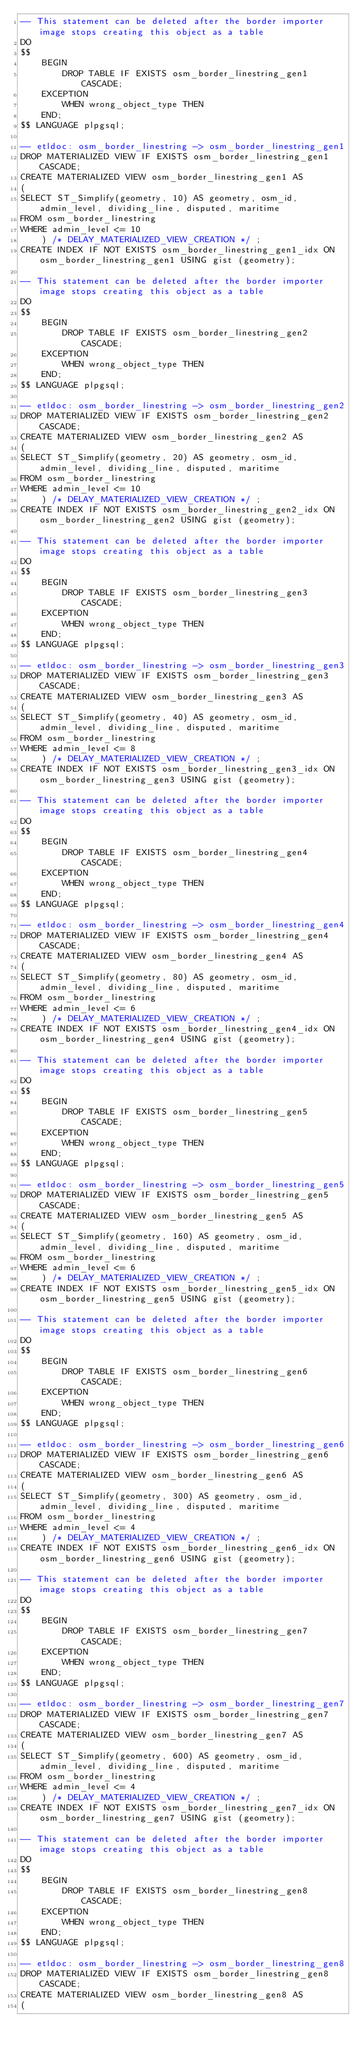<code> <loc_0><loc_0><loc_500><loc_500><_SQL_>-- This statement can be deleted after the border importer image stops creating this object as a table
DO
$$
    BEGIN
        DROP TABLE IF EXISTS osm_border_linestring_gen1 CASCADE;
    EXCEPTION
        WHEN wrong_object_type THEN
    END;
$$ LANGUAGE plpgsql;

-- etldoc: osm_border_linestring -> osm_border_linestring_gen1
DROP MATERIALIZED VIEW IF EXISTS osm_border_linestring_gen1 CASCADE;
CREATE MATERIALIZED VIEW osm_border_linestring_gen1 AS
(
SELECT ST_Simplify(geometry, 10) AS geometry, osm_id, admin_level, dividing_line, disputed, maritime
FROM osm_border_linestring
WHERE admin_level <= 10
    ) /* DELAY_MATERIALIZED_VIEW_CREATION */ ;
CREATE INDEX IF NOT EXISTS osm_border_linestring_gen1_idx ON osm_border_linestring_gen1 USING gist (geometry);

-- This statement can be deleted after the border importer image stops creating this object as a table
DO
$$
    BEGIN
        DROP TABLE IF EXISTS osm_border_linestring_gen2 CASCADE;
    EXCEPTION
        WHEN wrong_object_type THEN
    END;
$$ LANGUAGE plpgsql;

-- etldoc: osm_border_linestring -> osm_border_linestring_gen2
DROP MATERIALIZED VIEW IF EXISTS osm_border_linestring_gen2 CASCADE;
CREATE MATERIALIZED VIEW osm_border_linestring_gen2 AS
(
SELECT ST_Simplify(geometry, 20) AS geometry, osm_id, admin_level, dividing_line, disputed, maritime
FROM osm_border_linestring
WHERE admin_level <= 10
    ) /* DELAY_MATERIALIZED_VIEW_CREATION */ ;
CREATE INDEX IF NOT EXISTS osm_border_linestring_gen2_idx ON osm_border_linestring_gen2 USING gist (geometry);

-- This statement can be deleted after the border importer image stops creating this object as a table
DO
$$
    BEGIN
        DROP TABLE IF EXISTS osm_border_linestring_gen3 CASCADE;
    EXCEPTION
        WHEN wrong_object_type THEN
    END;
$$ LANGUAGE plpgsql;

-- etldoc: osm_border_linestring -> osm_border_linestring_gen3
DROP MATERIALIZED VIEW IF EXISTS osm_border_linestring_gen3 CASCADE;
CREATE MATERIALIZED VIEW osm_border_linestring_gen3 AS
(
SELECT ST_Simplify(geometry, 40) AS geometry, osm_id, admin_level, dividing_line, disputed, maritime
FROM osm_border_linestring
WHERE admin_level <= 8
    ) /* DELAY_MATERIALIZED_VIEW_CREATION */ ;
CREATE INDEX IF NOT EXISTS osm_border_linestring_gen3_idx ON osm_border_linestring_gen3 USING gist (geometry);

-- This statement can be deleted after the border importer image stops creating this object as a table
DO
$$
    BEGIN
        DROP TABLE IF EXISTS osm_border_linestring_gen4 CASCADE;
    EXCEPTION
        WHEN wrong_object_type THEN
    END;
$$ LANGUAGE plpgsql;

-- etldoc: osm_border_linestring -> osm_border_linestring_gen4
DROP MATERIALIZED VIEW IF EXISTS osm_border_linestring_gen4 CASCADE;
CREATE MATERIALIZED VIEW osm_border_linestring_gen4 AS
(
SELECT ST_Simplify(geometry, 80) AS geometry, osm_id, admin_level, dividing_line, disputed, maritime
FROM osm_border_linestring
WHERE admin_level <= 6
    ) /* DELAY_MATERIALIZED_VIEW_CREATION */ ;
CREATE INDEX IF NOT EXISTS osm_border_linestring_gen4_idx ON osm_border_linestring_gen4 USING gist (geometry);

-- This statement can be deleted after the border importer image stops creating this object as a table
DO
$$
    BEGIN
        DROP TABLE IF EXISTS osm_border_linestring_gen5 CASCADE;
    EXCEPTION
        WHEN wrong_object_type THEN
    END;
$$ LANGUAGE plpgsql;

-- etldoc: osm_border_linestring -> osm_border_linestring_gen5
DROP MATERIALIZED VIEW IF EXISTS osm_border_linestring_gen5 CASCADE;
CREATE MATERIALIZED VIEW osm_border_linestring_gen5 AS
(
SELECT ST_Simplify(geometry, 160) AS geometry, osm_id, admin_level, dividing_line, disputed, maritime
FROM osm_border_linestring
WHERE admin_level <= 6
    ) /* DELAY_MATERIALIZED_VIEW_CREATION */ ;
CREATE INDEX IF NOT EXISTS osm_border_linestring_gen5_idx ON osm_border_linestring_gen5 USING gist (geometry);

-- This statement can be deleted after the border importer image stops creating this object as a table
DO
$$
    BEGIN
        DROP TABLE IF EXISTS osm_border_linestring_gen6 CASCADE;
    EXCEPTION
        WHEN wrong_object_type THEN
    END;
$$ LANGUAGE plpgsql;

-- etldoc: osm_border_linestring -> osm_border_linestring_gen6
DROP MATERIALIZED VIEW IF EXISTS osm_border_linestring_gen6 CASCADE;
CREATE MATERIALIZED VIEW osm_border_linestring_gen6 AS
(
SELECT ST_Simplify(geometry, 300) AS geometry, osm_id, admin_level, dividing_line, disputed, maritime
FROM osm_border_linestring
WHERE admin_level <= 4
    ) /* DELAY_MATERIALIZED_VIEW_CREATION */ ;
CREATE INDEX IF NOT EXISTS osm_border_linestring_gen6_idx ON osm_border_linestring_gen6 USING gist (geometry);

-- This statement can be deleted after the border importer image stops creating this object as a table
DO
$$
    BEGIN
        DROP TABLE IF EXISTS osm_border_linestring_gen7 CASCADE;
    EXCEPTION
        WHEN wrong_object_type THEN
    END;
$$ LANGUAGE plpgsql;

-- etldoc: osm_border_linestring -> osm_border_linestring_gen7
DROP MATERIALIZED VIEW IF EXISTS osm_border_linestring_gen7 CASCADE;
CREATE MATERIALIZED VIEW osm_border_linestring_gen7 AS
(
SELECT ST_Simplify(geometry, 600) AS geometry, osm_id, admin_level, dividing_line, disputed, maritime
FROM osm_border_linestring
WHERE admin_level <= 4
    ) /* DELAY_MATERIALIZED_VIEW_CREATION */ ;
CREATE INDEX IF NOT EXISTS osm_border_linestring_gen7_idx ON osm_border_linestring_gen7 USING gist (geometry);

-- This statement can be deleted after the border importer image stops creating this object as a table
DO
$$
    BEGIN
        DROP TABLE IF EXISTS osm_border_linestring_gen8 CASCADE;
    EXCEPTION
        WHEN wrong_object_type THEN
    END;
$$ LANGUAGE plpgsql;

-- etldoc: osm_border_linestring -> osm_border_linestring_gen8
DROP MATERIALIZED VIEW IF EXISTS osm_border_linestring_gen8 CASCADE;
CREATE MATERIALIZED VIEW osm_border_linestring_gen8 AS
(</code> 